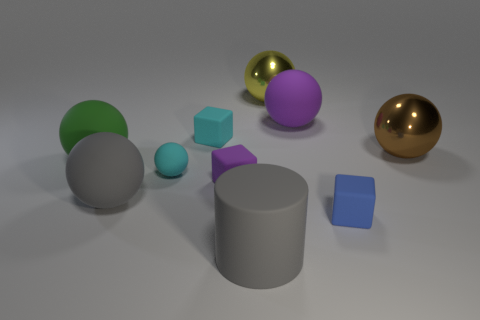Subtract 3 balls. How many balls are left? 3 Subtract all cyan balls. How many balls are left? 5 Subtract all yellow spheres. How many spheres are left? 5 Subtract all brown balls. Subtract all blue cylinders. How many balls are left? 5 Subtract all spheres. How many objects are left? 4 Subtract 0 purple cylinders. How many objects are left? 10 Subtract all cyan cubes. Subtract all large green balls. How many objects are left? 8 Add 6 large brown balls. How many large brown balls are left? 7 Add 3 large yellow matte cylinders. How many large yellow matte cylinders exist? 3 